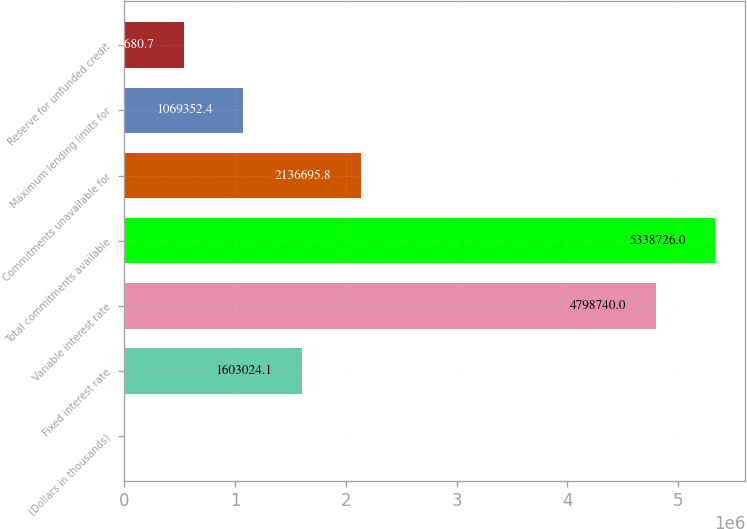Convert chart to OTSL. <chart><loc_0><loc_0><loc_500><loc_500><bar_chart><fcel>(Dollars in thousands)<fcel>Fixed interest rate<fcel>Variable interest rate<fcel>Total commitments available<fcel>Commitments unavailable for<fcel>Maximum lending limits for<fcel>Reserve for unfunded credit<nl><fcel>2009<fcel>1.60302e+06<fcel>4.79874e+06<fcel>5.33873e+06<fcel>2.1367e+06<fcel>1.06935e+06<fcel>535681<nl></chart> 